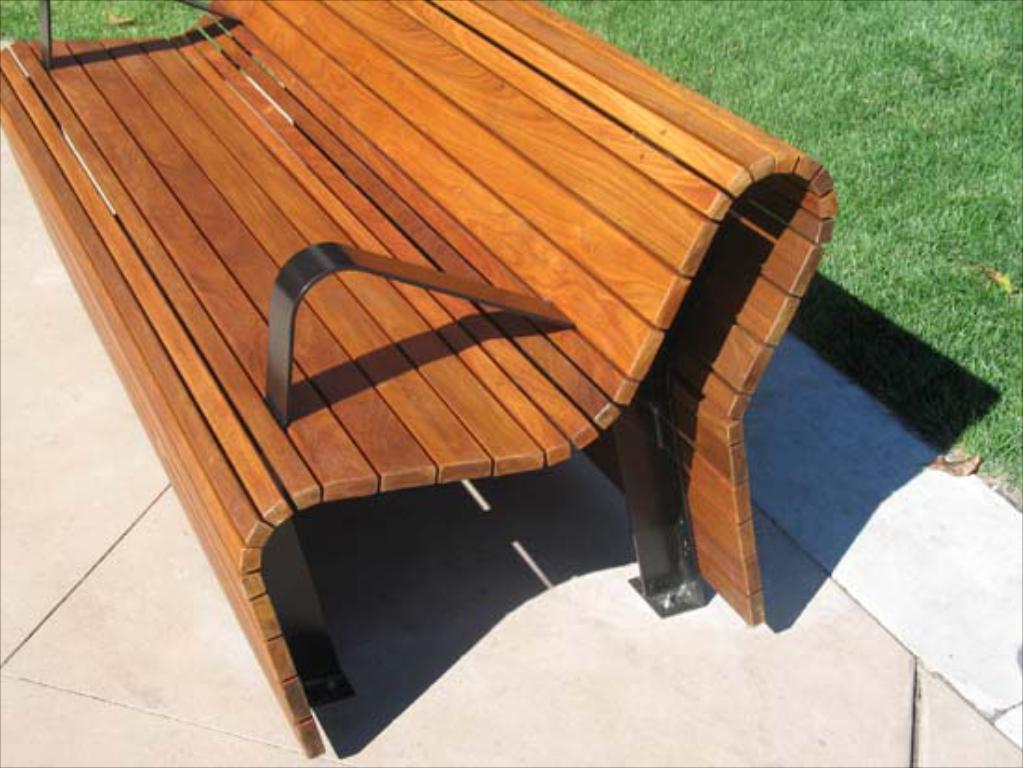What type of seating is present in the image? There is a bench in the image. Where is the bench located? The bench is on the ground. What type of vegetation can be seen in the background of the image? There is grass visible in the background of the image. How many gallons of fuel are stored under the bench in the image? There is no mention of fuel or any storage containers in the image, so it cannot be determined. 